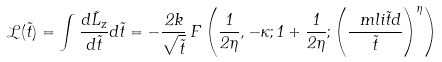Convert formula to latex. <formula><loc_0><loc_0><loc_500><loc_500>\mathcal { L } ( \tilde { t } ) = \int \frac { d \tilde { L } _ { z } } { d \tilde { t } } d \tilde { t } = - \frac { 2 k } { \sqrt { \tilde { t } } } \, F \left ( \frac { 1 } { 2 \eta } , - \kappa ; 1 + \frac { 1 } { 2 \eta } ; \left ( \frac { \ m l i { \tilde { t } } { d } } { \tilde { t } } \right ) ^ { \eta } \right ) \,</formula> 